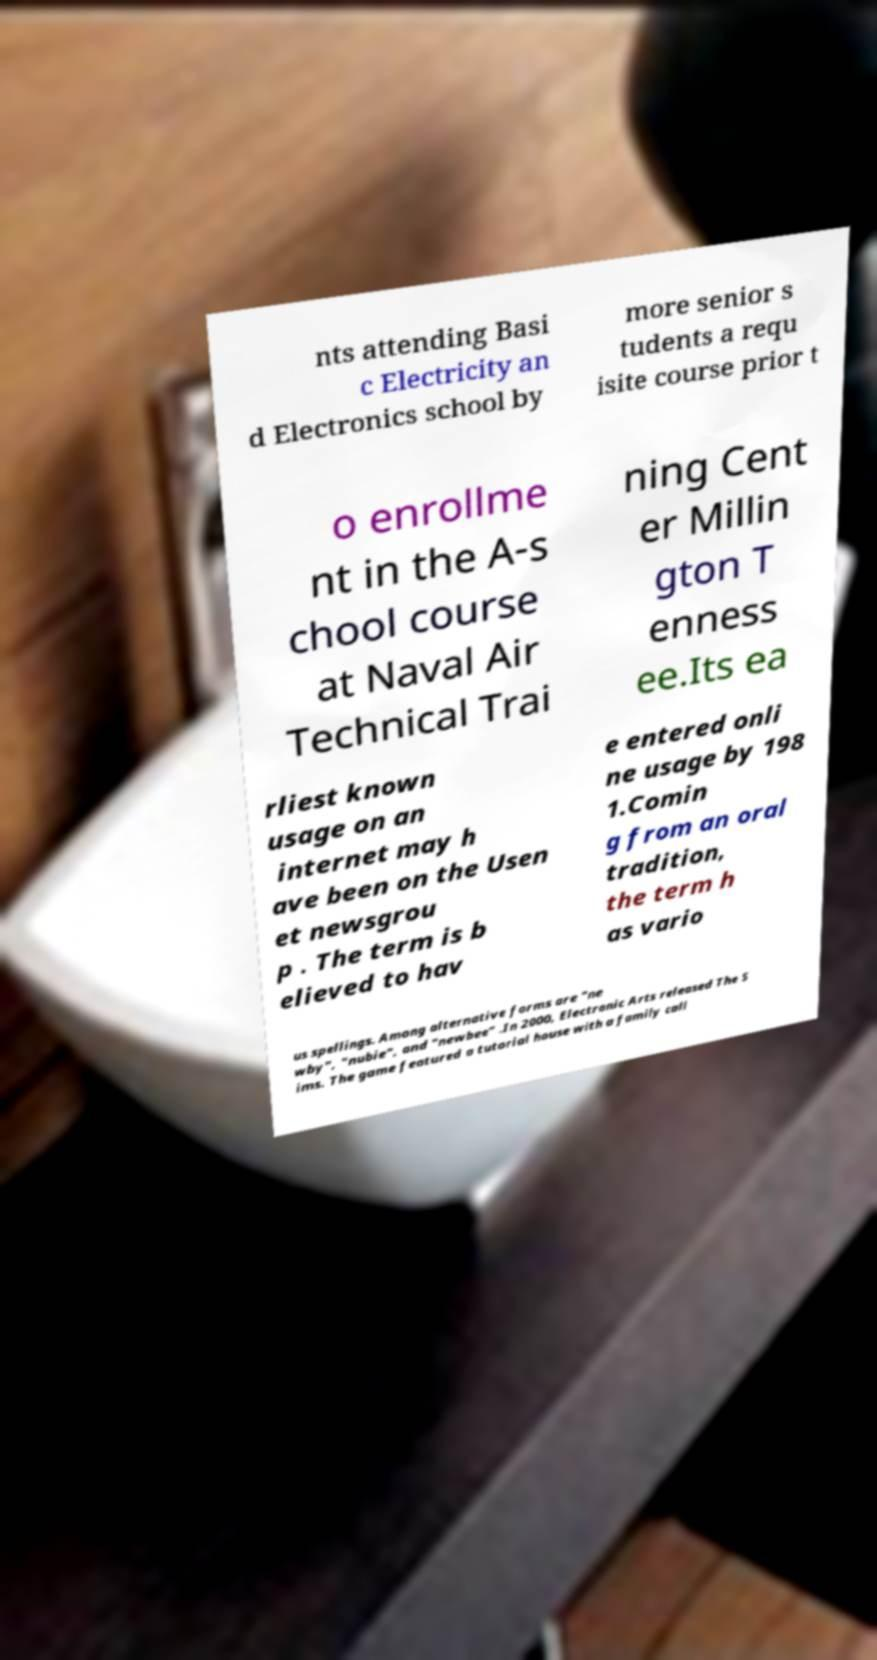Could you assist in decoding the text presented in this image and type it out clearly? nts attending Basi c Electricity an d Electronics school by more senior s tudents a requ isite course prior t o enrollme nt in the A-s chool course at Naval Air Technical Trai ning Cent er Millin gton T enness ee.Its ea rliest known usage on an internet may h ave been on the Usen et newsgrou p . The term is b elieved to hav e entered onli ne usage by 198 1.Comin g from an oral tradition, the term h as vario us spellings. Among alternative forms are "ne wby", "nubie", and "newbee" .In 2000, Electronic Arts released The S ims. The game featured a tutorial house with a family call 